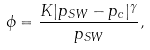<formula> <loc_0><loc_0><loc_500><loc_500>\phi = \frac { K | p _ { S W } - p _ { c } | ^ { \gamma } } { p _ { S W } } ,</formula> 